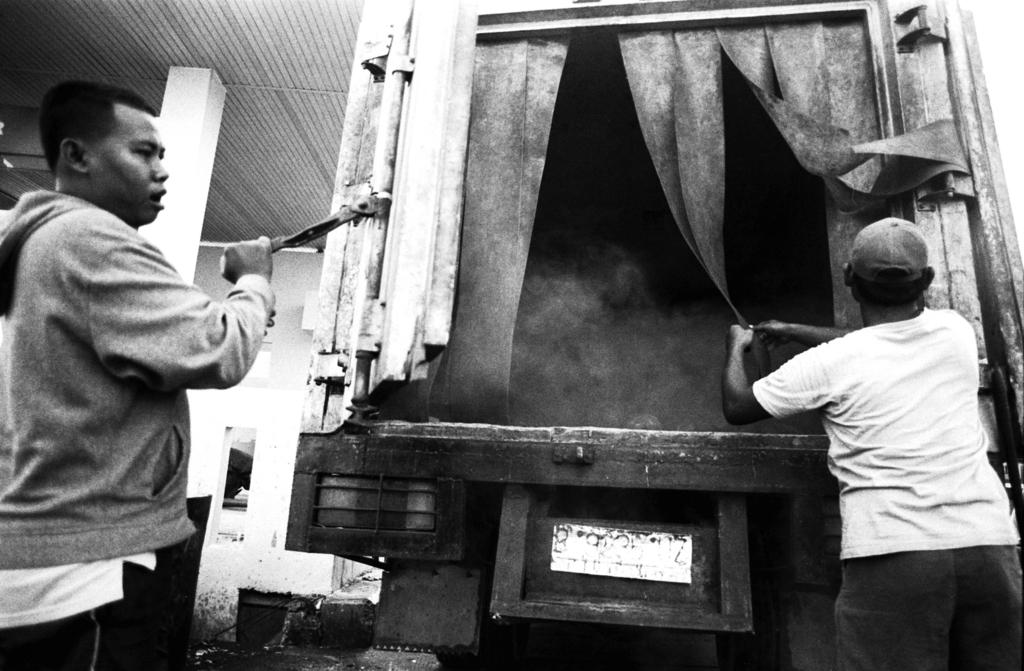What is the color scheme of the image? The image is black and white. How many people are in the image? There are two persons in the image. What vehicle can be seen in the image? There is a van in the image. Can you describe the bird that is attempting to fly in the image? There is no bird present in the image, and no attempt to fly is depicted. 